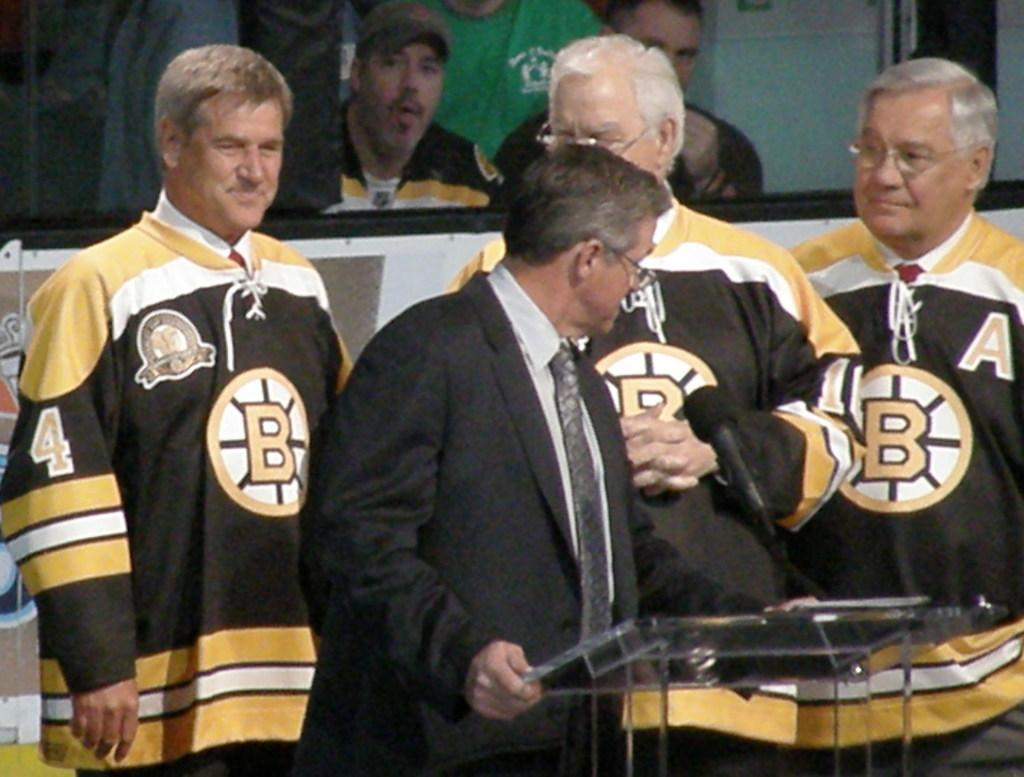<image>
Create a compact narrative representing the image presented. Three older gentlemen have a letter B on their jerseys. 